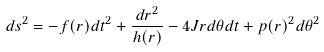<formula> <loc_0><loc_0><loc_500><loc_500>d s ^ { 2 } = - f ( r ) d t ^ { 2 } + \frac { d r ^ { 2 } } { h ( r ) } - 4 J r d \theta d t + p ( r ) ^ { 2 } d \theta ^ { 2 }</formula> 